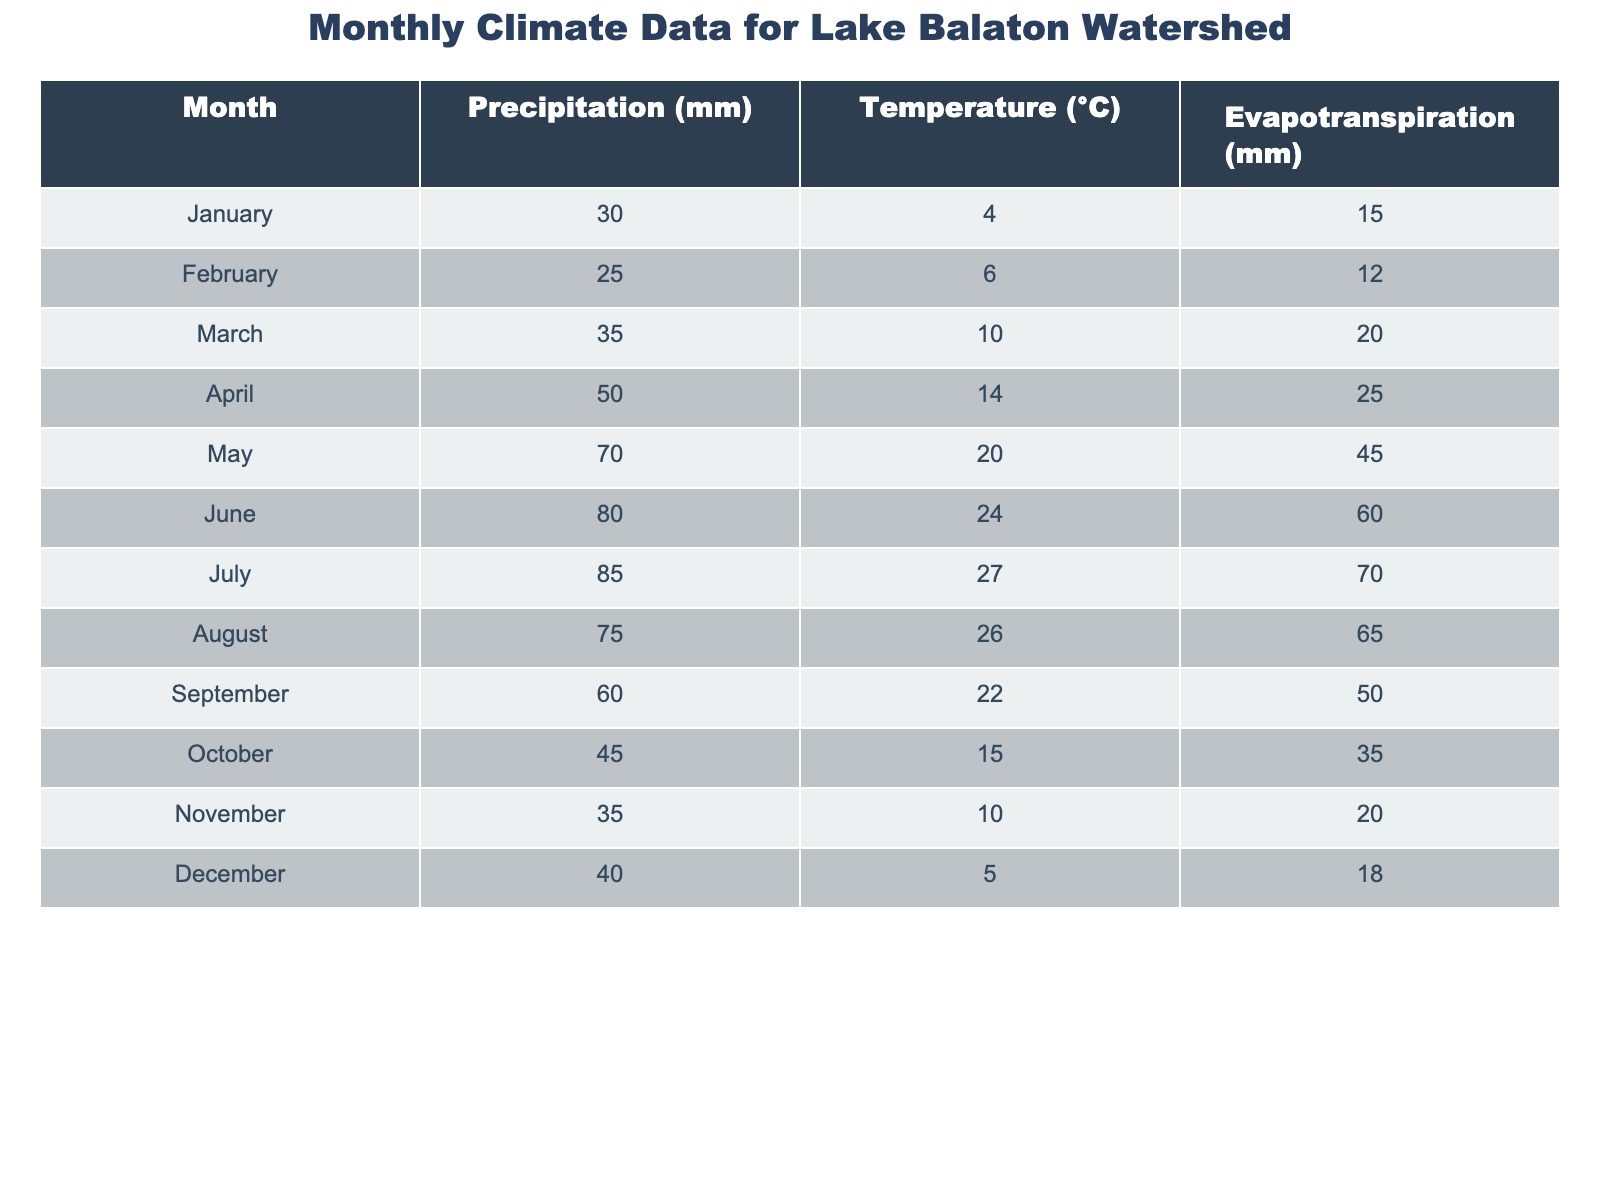What is the precipitation in July? The table shows that the precipitation for July is listed as 85 mm.
Answer: 85 mm What month recorded the highest temperature? By examining the temperature values, July has the highest temperature at 27 °C.
Answer: July What is the total precipitation from January to March? The precipitation values for January, February, and March are 30 mm, 25 mm, and 35 mm respectively. Summing these values gives 30 + 25 + 35 = 90 mm.
Answer: 90 mm Is the average temperature over the year higher than 15 °C? To find the average temperature, we sum all monthly temperatures (4 + 6 + 10 + 14 + 20 + 24 + 27 + 26 + 22 + 15 + 10 + 5 =  17.5 °C) and divide by 12 months, resulting in 17.5 °C which is greater than 15 °C.
Answer: Yes Which month has the lowest evapotranspiration? Looking at the evapotranspiration values, January has the lowest value at 15 mm.
Answer: January What is the difference in precipitation between May and August? The precipitation in May is 70 mm and in August, it is 75 mm. The difference is 75 - 70 = 5 mm.
Answer: 5 mm Which month has both the highest precipitation and highest temperature? July has the highest precipitation at 85 mm and the highest temperature at 27 °C, meeting both criteria.
Answer: July What is the average monthly precipitation for the entire year? To calculate the average precipitation, we sum all monthly precipitation values (like 30 + 25 + 35 + 50 + 70 + 80 + 85 + 75 + 60 + 45 + 35 + 40 =  665 mm) and divide by 12 months, resulting in 665/12 ≈ 55.42 mm.
Answer: 55.42 mm In which month does the precipitation exceed 80 mm? By reviewing the table, June, July, and August have precipitation values that exceed 80 mm, specifically June (80 mm), July (85 mm), and August (75 mm).
Answer: June and July What is the sum of evapotranspiration from October to December? The evapotranspiration values for October (35 mm), November (20 mm), and December (18 mm) sum up to 35 + 20 + 18 = 73 mm.
Answer: 73 mm 